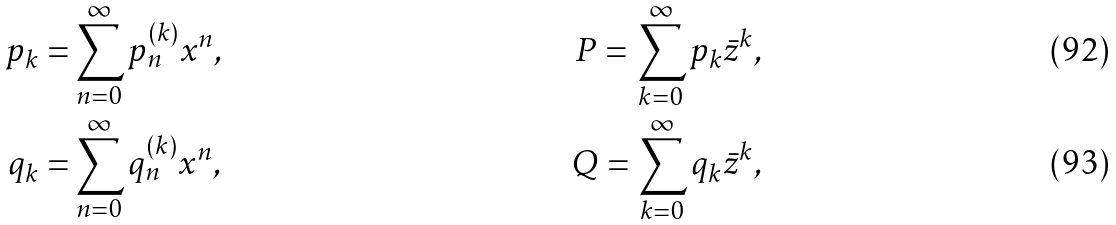<formula> <loc_0><loc_0><loc_500><loc_500>p _ { k } = & \sum _ { n = 0 } ^ { \infty } p _ { n } ^ { ( k ) } x ^ { n } , & P = \sum _ { k = 0 } ^ { \infty } p _ { k } { \bar { z } } ^ { k } , \\ q _ { k } = & \sum _ { n = 0 } ^ { \infty } q _ { n } ^ { ( k ) } x ^ { n } , & Q = \sum _ { k = 0 } ^ { \infty } q _ { k } { \bar { z } } ^ { k } ,</formula> 